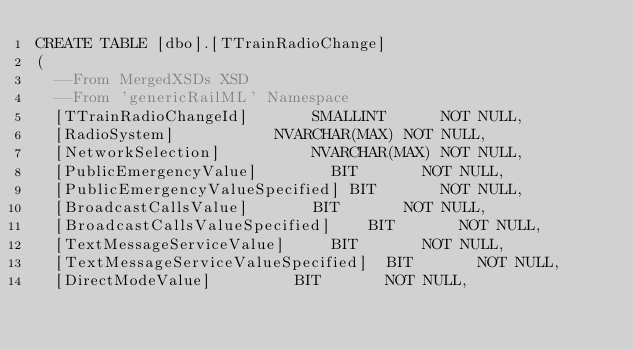<code> <loc_0><loc_0><loc_500><loc_500><_SQL_>CREATE TABLE [dbo].[TTrainRadioChange]
(
	--From MergedXSDs XSD
	--From 'genericRailML' Namespace
	[TTrainRadioChangeId]				SMALLINT			NOT NULL,
	[RadioSystem]						NVARCHAR(MAX)	NOT NULL,
	[NetworkSelection]					NVARCHAR(MAX)	NOT NULL,
	[PublicEmergencyValue]				BIT				NOT NULL,
	[PublicEmergencyValueSpecified]	BIT				NOT NULL,
	[BroadcastCallsValue]				BIT				NOT NULL,
	[BroadcastCallsValueSpecified]		BIT				NOT NULL,
	[TextMessageServiceValue]			BIT				NOT NULL,
	[TextMessageServiceValueSpecified]	BIT				NOT NULL,
	[DirectModeValue]					BIT				NOT NULL,</code> 